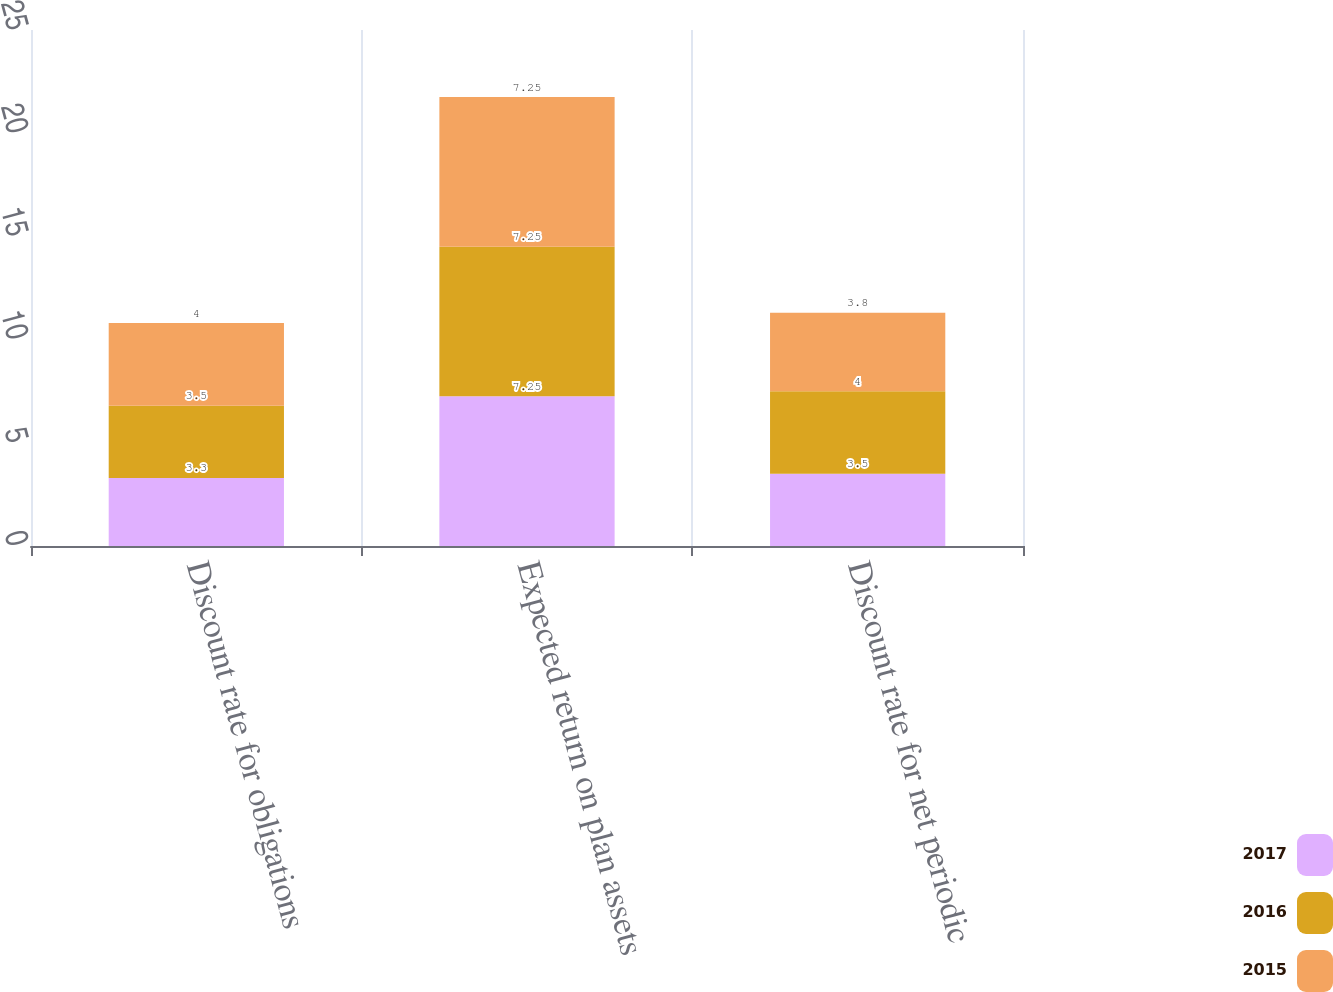Convert chart to OTSL. <chart><loc_0><loc_0><loc_500><loc_500><stacked_bar_chart><ecel><fcel>Discount rate for obligations<fcel>Expected return on plan assets<fcel>Discount rate for net periodic<nl><fcel>2017<fcel>3.3<fcel>7.25<fcel>3.5<nl><fcel>2016<fcel>3.5<fcel>7.25<fcel>4<nl><fcel>2015<fcel>4<fcel>7.25<fcel>3.8<nl></chart> 